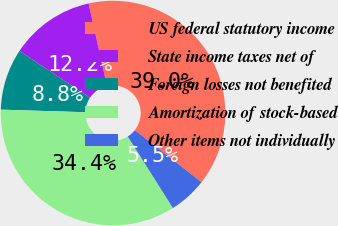Convert chart. <chart><loc_0><loc_0><loc_500><loc_500><pie_chart><fcel>US federal statutory income<fcel>State income taxes net of<fcel>Foreign losses not benefited<fcel>Amortization of stock-based<fcel>Other items not individually<nl><fcel>39.04%<fcel>12.19%<fcel>8.84%<fcel>34.44%<fcel>5.49%<nl></chart> 